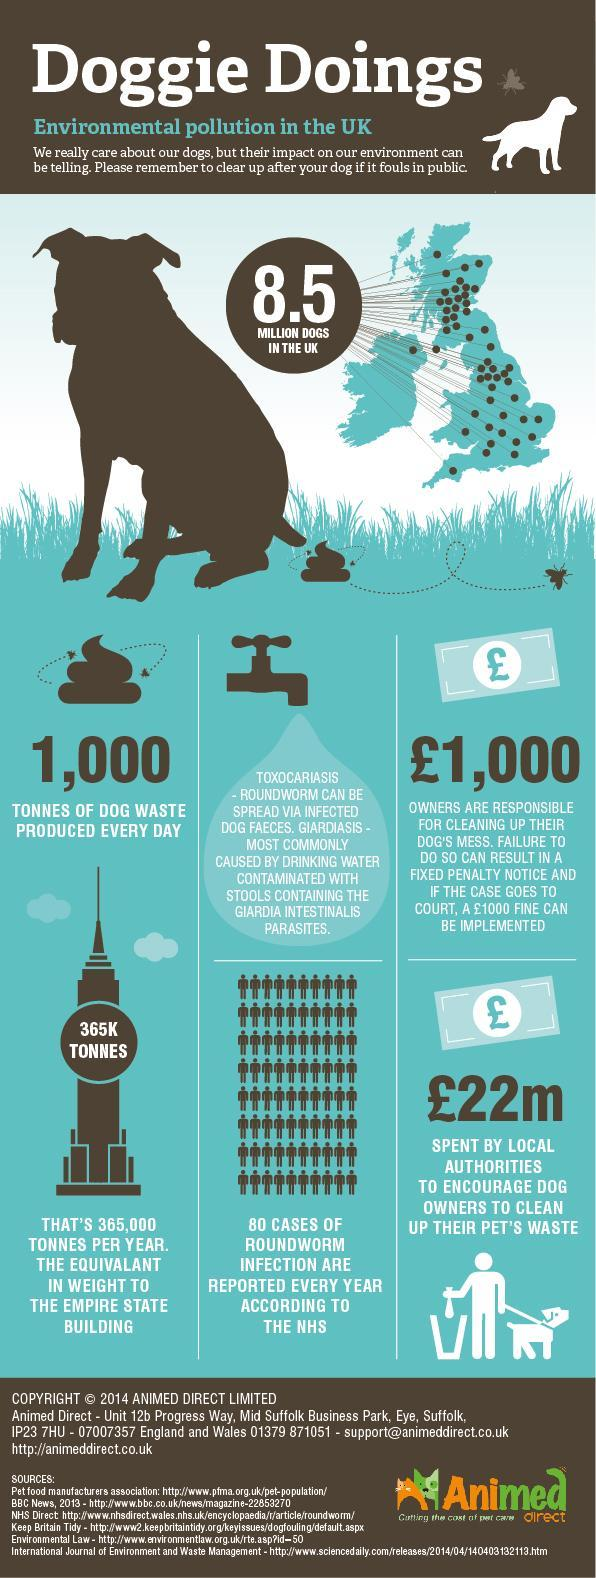How many sources are listed at the bottom?
Answer the question with a short phrase. 6 How many people are affected every year due to roundworm? 80 CASES Which famous landmark is mentioned? THE EMPIRE STATE BUILDING 